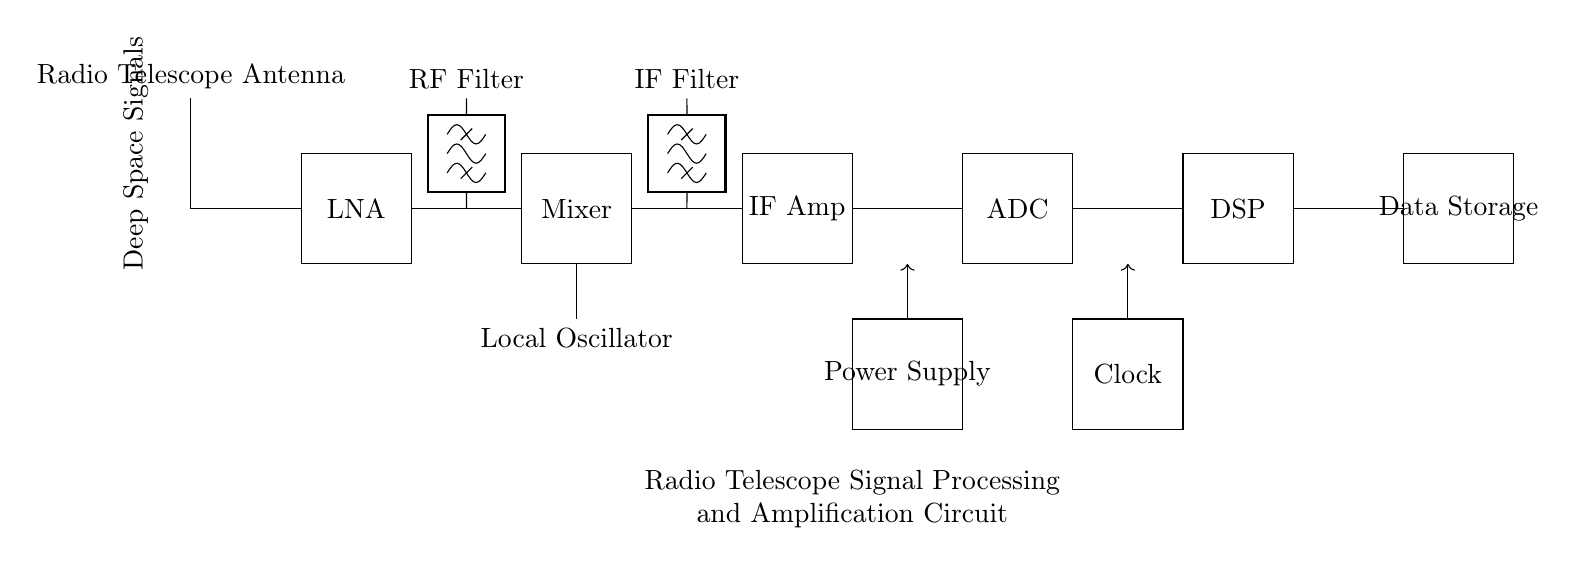What component amplifies weak deep space signals? The Low Noise Amplifier (LNA) is responsible for amplifying weak radio signals received from deep space, ensuring they are strong enough for further processing.
Answer: LNA What follows the mixer in the signal processing chain? The Intermediate Frequency Amplifier (IF Amp) follows directly after the mixer, which combines the signals to produce a lower frequency that is easier to amplify.
Answer: IF Amp How many filters are present in the circuit? There are two filters depicted in the circuit: one is an RF Filter, and the other is an IF Filter, each serving to refine specific frequency ranges of the signals.
Answer: 2 What is the purpose of the Analog-to-Digital Converter? The ADC converts the analog signals processed by the IF Amplifier into digital format for further digital signal processing, essential for modern data manipulation.
Answer: Convert analog to digital Which component provides the necessary power for the circuit? The Power Supply supplies the necessary electrical energy to all components in the circuit, enabling them to operate correctly.
Answer: Power Supply What is the role of the Digital Signal Processor? The Digital Signal Processor (DSP) processes the converted digital signals to extract meaningful data and perform complex computations on the received signals.
Answer: DSP What signals are being received by the radio telescope? The radio telescope is designed to receive deep space signals that originate from cosmic phenomena, such as stars and galaxies.
Answer: Deep space signals 